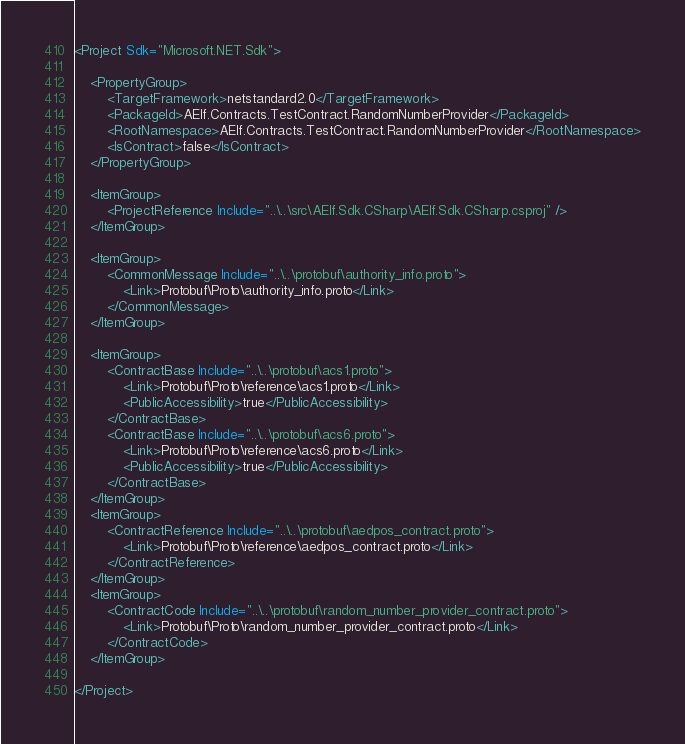Convert code to text. <code><loc_0><loc_0><loc_500><loc_500><_XML_><Project Sdk="Microsoft.NET.Sdk">

    <PropertyGroup>
        <TargetFramework>netstandard2.0</TargetFramework>
        <PackageId>AElf.Contracts.TestContract.RandomNumberProvider</PackageId>
        <RootNamespace>AElf.Contracts.TestContract.RandomNumberProvider</RootNamespace>
        <IsContract>false</IsContract>
    </PropertyGroup>

    <ItemGroup>
        <ProjectReference Include="..\..\src\AElf.Sdk.CSharp\AElf.Sdk.CSharp.csproj" />
    </ItemGroup>

    <ItemGroup>
        <CommonMessage Include="..\..\protobuf\authority_info.proto">
            <Link>Protobuf\Proto\authority_info.proto</Link>
        </CommonMessage>
    </ItemGroup>
    
    <ItemGroup>
        <ContractBase Include="..\..\protobuf\acs1.proto">
            <Link>Protobuf\Proto\reference\acs1.proto</Link>
            <PublicAccessibility>true</PublicAccessibility>
        </ContractBase>
        <ContractBase Include="..\..\protobuf\acs6.proto">
            <Link>Protobuf\Proto\reference\acs6.proto</Link>
            <PublicAccessibility>true</PublicAccessibility>
        </ContractBase>
    </ItemGroup>
    <ItemGroup>
        <ContractReference Include="..\..\protobuf\aedpos_contract.proto">
            <Link>Protobuf\Proto\reference\aedpos_contract.proto</Link>
        </ContractReference>
    </ItemGroup>
    <ItemGroup>
        <ContractCode Include="..\..\protobuf\random_number_provider_contract.proto">
            <Link>Protobuf\Proto\random_number_provider_contract.proto</Link>
        </ContractCode>
    </ItemGroup>

</Project>

</code> 